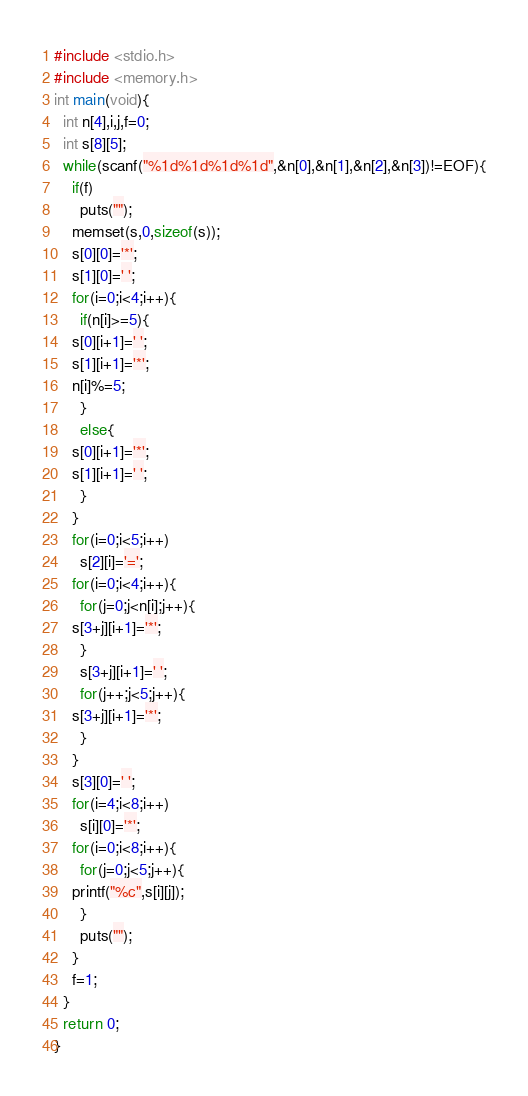<code> <loc_0><loc_0><loc_500><loc_500><_C_>#include <stdio.h>
#include <memory.h>
int main(void){
  int n[4],i,j,f=0;
  int s[8][5];
  while(scanf("%1d%1d%1d%1d",&n[0],&n[1],&n[2],&n[3])!=EOF){
    if(f)
      puts("");
    memset(s,0,sizeof(s));
    s[0][0]='*';
    s[1][0]=' ';
    for(i=0;i<4;i++){
      if(n[i]>=5){
	s[0][i+1]=' ';
	s[1][i+1]='*';
	n[i]%=5;
      }
      else{
	s[0][i+1]='*';
	s[1][i+1]=' ';
      }
    }
    for(i=0;i<5;i++)
      s[2][i]='=';
    for(i=0;i<4;i++){
      for(j=0;j<n[i];j++){
	s[3+j][i+1]='*';
      }
      s[3+j][i+1]=' ';
      for(j++;j<5;j++){
	s[3+j][i+1]='*';
      }
    }
    s[3][0]=' ';
    for(i=4;i<8;i++)
      s[i][0]='*';
    for(i=0;i<8;i++){
      for(j=0;j<5;j++){
	printf("%c",s[i][j]);
      }
      puts("");
    }
    f=1;
  }
  return 0;
}</code> 